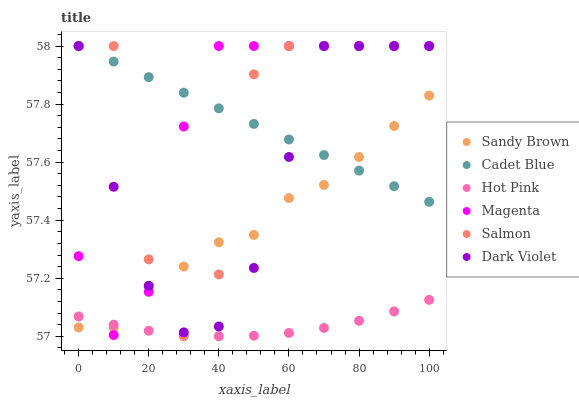Does Hot Pink have the minimum area under the curve?
Answer yes or no. Yes. Does Magenta have the maximum area under the curve?
Answer yes or no. Yes. Does Salmon have the minimum area under the curve?
Answer yes or no. No. Does Salmon have the maximum area under the curve?
Answer yes or no. No. Is Cadet Blue the smoothest?
Answer yes or no. Yes. Is Salmon the roughest?
Answer yes or no. Yes. Is Hot Pink the smoothest?
Answer yes or no. No. Is Hot Pink the roughest?
Answer yes or no. No. Does Hot Pink have the lowest value?
Answer yes or no. Yes. Does Salmon have the lowest value?
Answer yes or no. No. Does Magenta have the highest value?
Answer yes or no. Yes. Does Hot Pink have the highest value?
Answer yes or no. No. Is Hot Pink less than Dark Violet?
Answer yes or no. Yes. Is Cadet Blue greater than Hot Pink?
Answer yes or no. Yes. Does Salmon intersect Hot Pink?
Answer yes or no. Yes. Is Salmon less than Hot Pink?
Answer yes or no. No. Is Salmon greater than Hot Pink?
Answer yes or no. No. Does Hot Pink intersect Dark Violet?
Answer yes or no. No. 